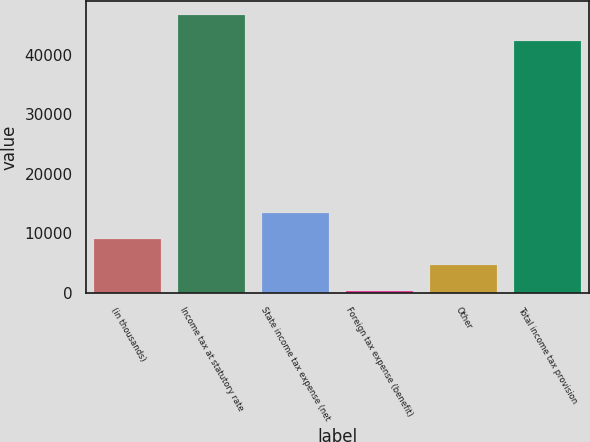Convert chart to OTSL. <chart><loc_0><loc_0><loc_500><loc_500><bar_chart><fcel>(in thousands)<fcel>Income tax at statutory rate<fcel>State income tax expense (net<fcel>Foreign tax expense (benefit)<fcel>Other<fcel>Total income tax provision<nl><fcel>9081.2<fcel>46697.1<fcel>13471.3<fcel>301<fcel>4691.1<fcel>42307<nl></chart> 